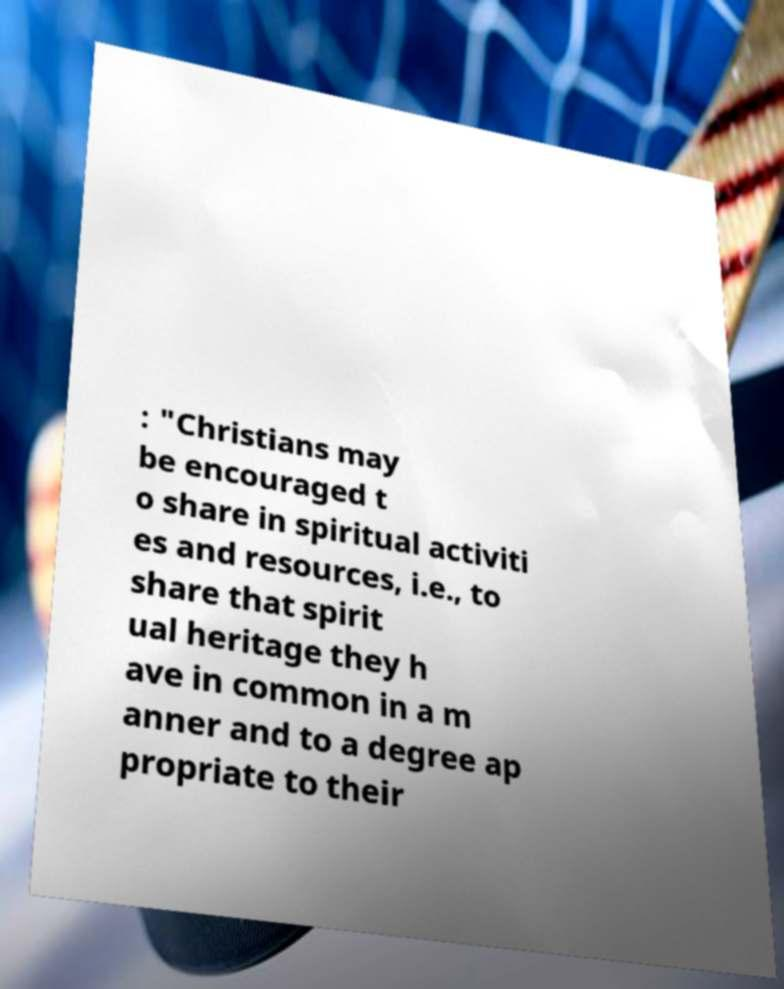Could you assist in decoding the text presented in this image and type it out clearly? : "Christians may be encouraged t o share in spiritual activiti es and resources, i.e., to share that spirit ual heritage they h ave in common in a m anner and to a degree ap propriate to their 